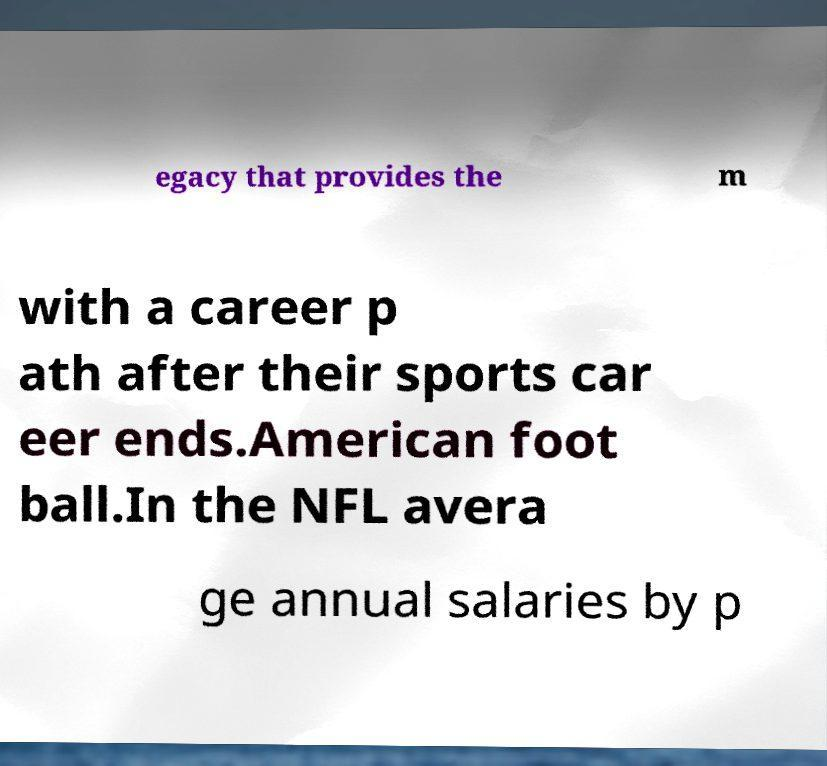I need the written content from this picture converted into text. Can you do that? egacy that provides the m with a career p ath after their sports car eer ends.American foot ball.In the NFL avera ge annual salaries by p 